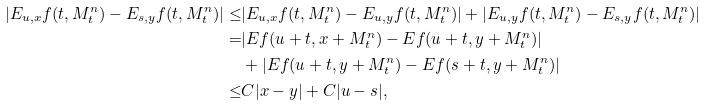Convert formula to latex. <formula><loc_0><loc_0><loc_500><loc_500>| E _ { u , x } f ( t , M _ { t } ^ { n } ) - E _ { s , y } f ( t , M _ { t } ^ { n } ) | \leq & | E _ { u , x } f ( t , M _ { t } ^ { n } ) - E _ { u , y } f ( t , M _ { t } ^ { n } ) | + | E _ { u , y } f ( t , M _ { t } ^ { n } ) - E _ { s , y } f ( t , M _ { t } ^ { n } ) | \\ = & | E f ( u + t , x + M _ { t } ^ { n } ) - E f ( u + t , y + M _ { t } ^ { n } ) | \\ & + | E f ( u + t , y + M _ { t } ^ { n } ) - E f ( s + t , y + M _ { t } ^ { n } ) | \\ \leq & C | x - y | + C | u - s | ,</formula> 